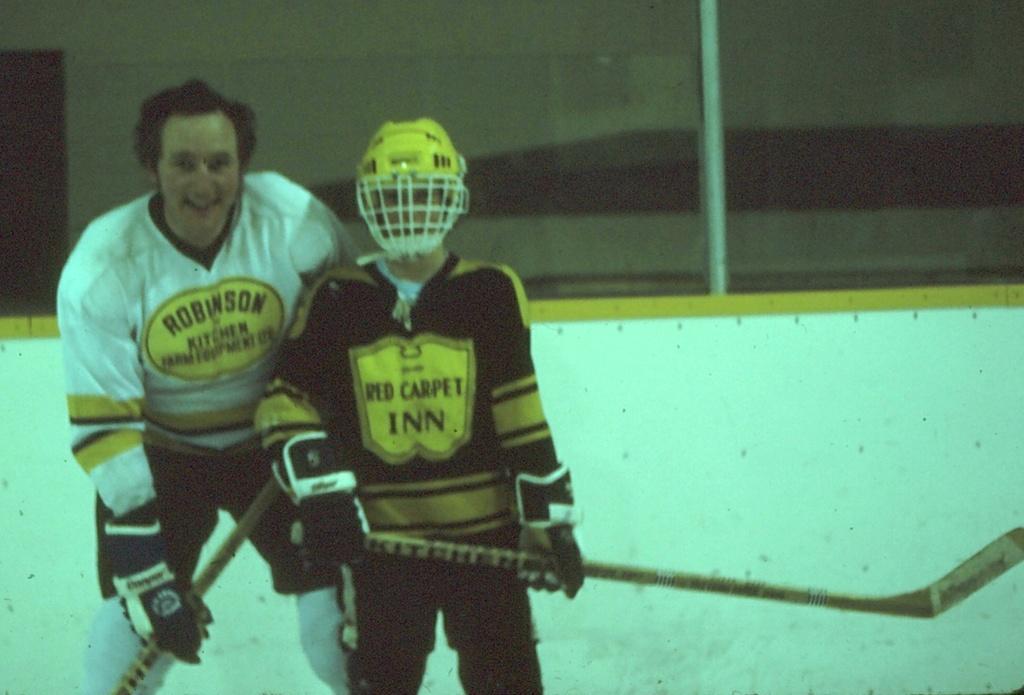Could you give a brief overview of what you see in this image? In this picture we can see there are two people standing on the path and holding the sticks. Behind the people there is a wall. 